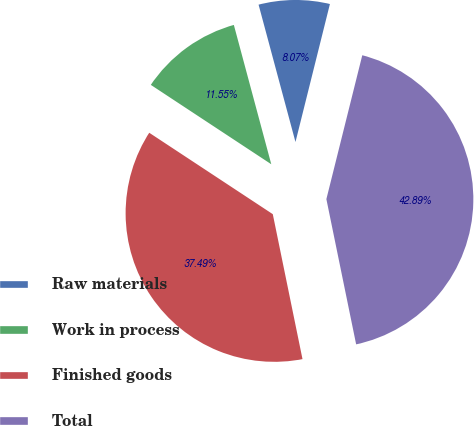Convert chart to OTSL. <chart><loc_0><loc_0><loc_500><loc_500><pie_chart><fcel>Raw materials<fcel>Work in process<fcel>Finished goods<fcel>Total<nl><fcel>8.07%<fcel>11.55%<fcel>37.49%<fcel>42.89%<nl></chart> 